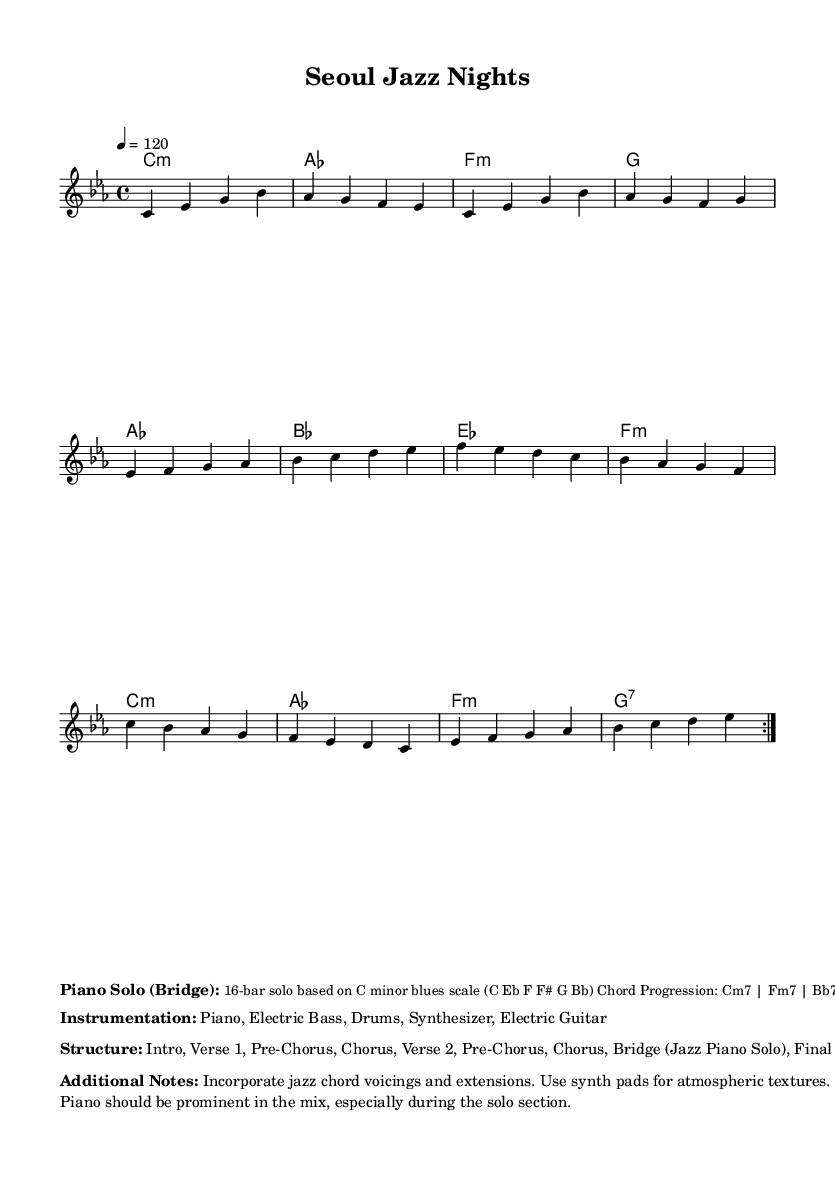What is the key signature of this music? The key signature is C minor, which has three flats (B♭, E♭, and A♭). This is indicated at the beginning of the music sheet.
Answer: C minor What is the time signature of this piece? The time signature of the piece is indicated as 4/4, meaning there are four beats in a measure, and the quarter note gets one beat. This is also specified at the beginning of the sheet music.
Answer: 4/4 What is the tempo marking of the music? The tempo marking is given as "4 = 120," which indicates that the quarter note should be played at a speed of 120 beats per minute. This is found in the global context of the sheet music at the start.
Answer: 120 How many bars are included in the piano solo section? The piano solo section described as the bridge is specified to be 16 bars long in the markup section. This directly informs us of the length of that specific part.
Answer: 16 bars Which instruments are included in the ensemble? The instrumentation listed in the markup includes Piano, Electric Bass, Drums, Synthesizer, and Electric Guitar, as specified in the column of notes beyond the musical notation.
Answer: Piano, Electric Bass, Drums, Synthesizer, Electric Guitar What structure does the piece follow? The structure follows a sequence of Intro, Verse 1, Pre-Chorus, Chorus, Verse 2, Pre-Chorus, Chorus, Bridge (Jazz Piano Solo), Final Chorus, Outro, which is laid out in the markup section under "Structure."
Answer: Intro, Verse 1, Pre-Chorus, Chorus, Verse 2, Pre-Chorus, Chorus, Bridge, Final Chorus, Outro 